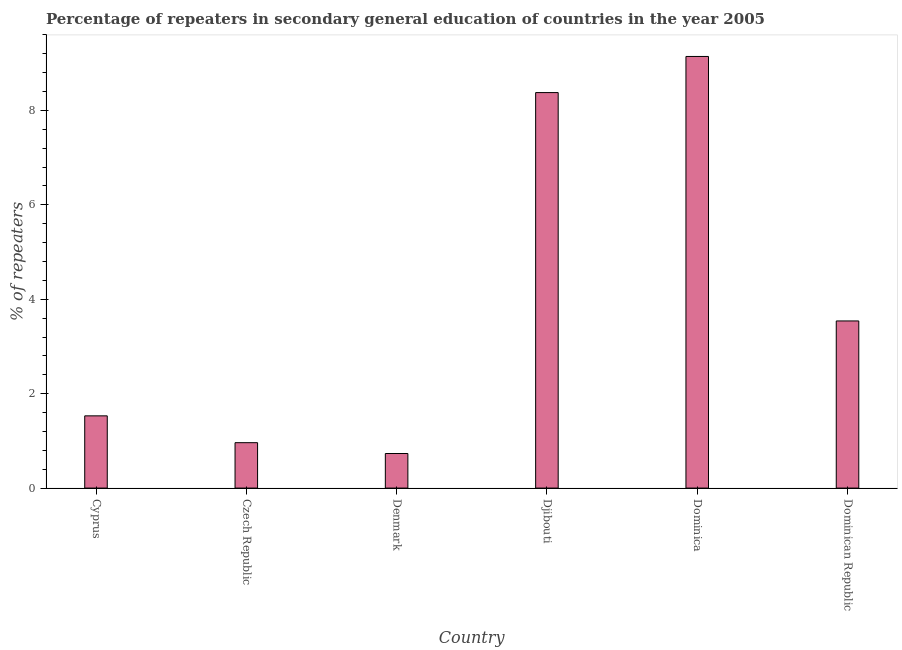Does the graph contain any zero values?
Keep it short and to the point. No. Does the graph contain grids?
Provide a succinct answer. No. What is the title of the graph?
Ensure brevity in your answer.  Percentage of repeaters in secondary general education of countries in the year 2005. What is the label or title of the Y-axis?
Your answer should be very brief. % of repeaters. What is the percentage of repeaters in Czech Republic?
Keep it short and to the point. 0.96. Across all countries, what is the maximum percentage of repeaters?
Make the answer very short. 9.14. Across all countries, what is the minimum percentage of repeaters?
Make the answer very short. 0.73. In which country was the percentage of repeaters maximum?
Provide a short and direct response. Dominica. What is the sum of the percentage of repeaters?
Make the answer very short. 24.29. What is the difference between the percentage of repeaters in Dominica and Dominican Republic?
Provide a short and direct response. 5.6. What is the average percentage of repeaters per country?
Provide a succinct answer. 4.05. What is the median percentage of repeaters?
Your answer should be very brief. 2.54. In how many countries, is the percentage of repeaters greater than 1.6 %?
Your answer should be compact. 3. What is the ratio of the percentage of repeaters in Cyprus to that in Djibouti?
Give a very brief answer. 0.18. Is the difference between the percentage of repeaters in Denmark and Dominica greater than the difference between any two countries?
Offer a terse response. Yes. What is the difference between the highest and the second highest percentage of repeaters?
Make the answer very short. 0.77. What is the difference between the highest and the lowest percentage of repeaters?
Make the answer very short. 8.41. How many bars are there?
Give a very brief answer. 6. How many countries are there in the graph?
Your response must be concise. 6. What is the difference between two consecutive major ticks on the Y-axis?
Offer a terse response. 2. Are the values on the major ticks of Y-axis written in scientific E-notation?
Your answer should be very brief. No. What is the % of repeaters of Cyprus?
Offer a terse response. 1.53. What is the % of repeaters in Czech Republic?
Offer a terse response. 0.96. What is the % of repeaters of Denmark?
Provide a short and direct response. 0.73. What is the % of repeaters in Djibouti?
Provide a succinct answer. 8.38. What is the % of repeaters of Dominica?
Your answer should be compact. 9.14. What is the % of repeaters in Dominican Republic?
Provide a short and direct response. 3.54. What is the difference between the % of repeaters in Cyprus and Czech Republic?
Your response must be concise. 0.57. What is the difference between the % of repeaters in Cyprus and Denmark?
Make the answer very short. 0.8. What is the difference between the % of repeaters in Cyprus and Djibouti?
Ensure brevity in your answer.  -6.85. What is the difference between the % of repeaters in Cyprus and Dominica?
Give a very brief answer. -7.61. What is the difference between the % of repeaters in Cyprus and Dominican Republic?
Provide a short and direct response. -2.01. What is the difference between the % of repeaters in Czech Republic and Denmark?
Your answer should be very brief. 0.23. What is the difference between the % of repeaters in Czech Republic and Djibouti?
Offer a very short reply. -7.42. What is the difference between the % of repeaters in Czech Republic and Dominica?
Provide a succinct answer. -8.18. What is the difference between the % of repeaters in Czech Republic and Dominican Republic?
Offer a terse response. -2.58. What is the difference between the % of repeaters in Denmark and Djibouti?
Keep it short and to the point. -7.65. What is the difference between the % of repeaters in Denmark and Dominica?
Give a very brief answer. -8.41. What is the difference between the % of repeaters in Denmark and Dominican Republic?
Provide a short and direct response. -2.81. What is the difference between the % of repeaters in Djibouti and Dominica?
Your answer should be very brief. -0.77. What is the difference between the % of repeaters in Djibouti and Dominican Republic?
Provide a short and direct response. 4.84. What is the difference between the % of repeaters in Dominica and Dominican Republic?
Make the answer very short. 5.6. What is the ratio of the % of repeaters in Cyprus to that in Czech Republic?
Keep it short and to the point. 1.59. What is the ratio of the % of repeaters in Cyprus to that in Denmark?
Your response must be concise. 2.09. What is the ratio of the % of repeaters in Cyprus to that in Djibouti?
Keep it short and to the point. 0.18. What is the ratio of the % of repeaters in Cyprus to that in Dominica?
Provide a short and direct response. 0.17. What is the ratio of the % of repeaters in Cyprus to that in Dominican Republic?
Your response must be concise. 0.43. What is the ratio of the % of repeaters in Czech Republic to that in Denmark?
Offer a very short reply. 1.31. What is the ratio of the % of repeaters in Czech Republic to that in Djibouti?
Offer a very short reply. 0.12. What is the ratio of the % of repeaters in Czech Republic to that in Dominica?
Your response must be concise. 0.1. What is the ratio of the % of repeaters in Czech Republic to that in Dominican Republic?
Give a very brief answer. 0.27. What is the ratio of the % of repeaters in Denmark to that in Djibouti?
Provide a succinct answer. 0.09. What is the ratio of the % of repeaters in Denmark to that in Dominican Republic?
Provide a succinct answer. 0.21. What is the ratio of the % of repeaters in Djibouti to that in Dominica?
Give a very brief answer. 0.92. What is the ratio of the % of repeaters in Djibouti to that in Dominican Republic?
Your answer should be very brief. 2.37. What is the ratio of the % of repeaters in Dominica to that in Dominican Republic?
Give a very brief answer. 2.58. 